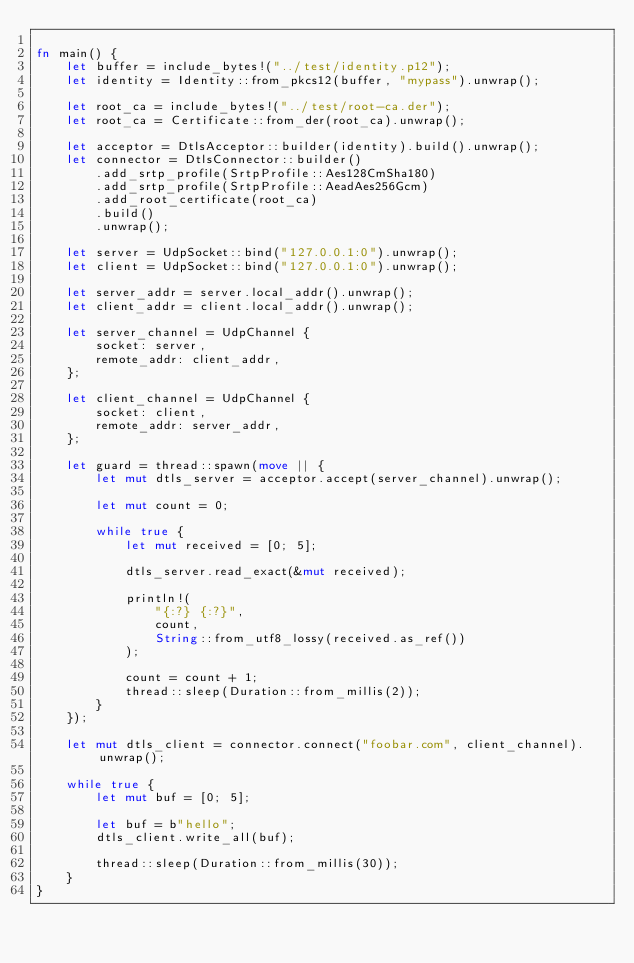Convert code to text. <code><loc_0><loc_0><loc_500><loc_500><_Rust_>
fn main() {
    let buffer = include_bytes!("../test/identity.p12");
    let identity = Identity::from_pkcs12(buffer, "mypass").unwrap();

    let root_ca = include_bytes!("../test/root-ca.der");
    let root_ca = Certificate::from_der(root_ca).unwrap();

    let acceptor = DtlsAcceptor::builder(identity).build().unwrap();
    let connector = DtlsConnector::builder()
        .add_srtp_profile(SrtpProfile::Aes128CmSha180)
        .add_srtp_profile(SrtpProfile::AeadAes256Gcm)
        .add_root_certificate(root_ca)
        .build()
        .unwrap();

    let server = UdpSocket::bind("127.0.0.1:0").unwrap();
    let client = UdpSocket::bind("127.0.0.1:0").unwrap();

    let server_addr = server.local_addr().unwrap();
    let client_addr = client.local_addr().unwrap();

    let server_channel = UdpChannel {
        socket: server,
        remote_addr: client_addr,
    };

    let client_channel = UdpChannel {
        socket: client,
        remote_addr: server_addr,
    };

    let guard = thread::spawn(move || {
        let mut dtls_server = acceptor.accept(server_channel).unwrap();

        let mut count = 0;

        while true {
            let mut received = [0; 5];

            dtls_server.read_exact(&mut received);

            println!(
                "{:?} {:?}",
                count,
                String::from_utf8_lossy(received.as_ref())
            );

            count = count + 1;
            thread::sleep(Duration::from_millis(2));
        }
    });

    let mut dtls_client = connector.connect("foobar.com", client_channel).unwrap();

    while true {
        let mut buf = [0; 5];

        let buf = b"hello";
        dtls_client.write_all(buf);

        thread::sleep(Duration::from_millis(30));
    }
}
</code> 